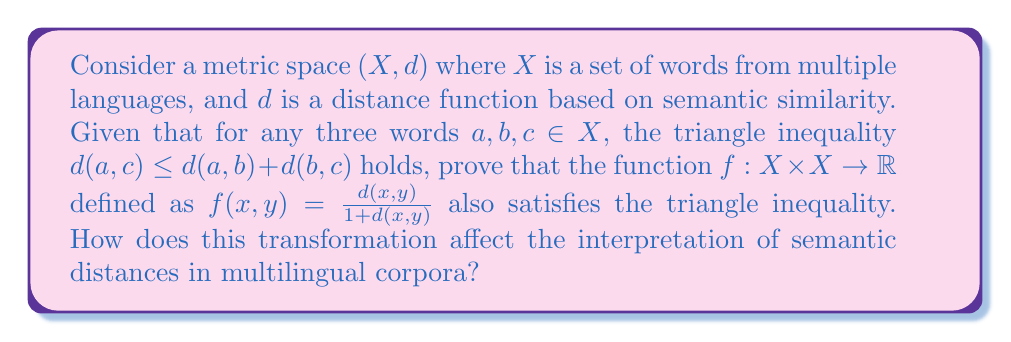Can you answer this question? To prove that $f(x,y) = \frac{d(x,y)}{1 + d(x,y)}$ satisfies the triangle inequality, we need to show that for any $a, b, c \in X$:

$$f(a,c) \leq f(a,b) + f(b,c)$$

Let's approach this step-by-step:

1) First, we know that $d(a,c) \leq d(a,b) + d(b,c)$ (given triangle inequality for $d$).

2) Divide both sides by $1 + d(a,c)$:

   $$\frac{d(a,c)}{1 + d(a,c)} \leq \frac{d(a,b) + d(b,c)}{1 + d(a,c)}$$

3) The left side is now $f(a,c)$. We need to show that the right side is $\leq f(a,b) + f(b,c)$.

4) Consider the function $g(x) = \frac{x}{1+x}$ for $x \geq 0$. This function is increasing and concave, which means:

   $$g(x+y) \leq g(x) + g(y)$$ for all $x,y \geq 0$

5) Applying this to our case:

   $$\frac{d(a,b) + d(b,c)}{1 + (d(a,b) + d(b,c))} \leq \frac{d(a,b)}{1 + d(a,b)} + \frac{d(b,c)}{1 + d(b,c)} = f(a,b) + f(b,c)$$

6) Since $d(a,c) \leq d(a,b) + d(b,c)$, we have $1 + d(a,c) \leq 1 + (d(a,b) + d(b,c))$

7) Therefore:

   $$\frac{d(a,b) + d(b,c)}{1 + d(a,c)} \geq \frac{d(a,b) + d(b,c)}{1 + (d(a,b) + d(b,c))}$$

8) Combining steps 2, 5, and 7:

   $$f(a,c) = \frac{d(a,c)}{1 + d(a,c)} \leq \frac{d(a,b) + d(b,c)}{1 + d(a,c)} \leq f(a,b) + f(b,c)$$

Thus, we have proved that $f$ satisfies the triangle inequality.

Regarding the interpretation of semantic distances in multilingual corpora:

1) The transformation $f(x,y) = \frac{d(x,y)}{1 + d(x,y)}$ maps the original distances to the interval $[0,1)$.

2) This normalization can be helpful when comparing semantic distances across different language pairs or different semantic spaces.

3) The transformation preserves the order of distances but compresses larger distances more than smaller ones. This means that in the transformed space, very distant concepts appear relatively closer, while maintaining the distinction between closely related concepts.

4) This compression effect could be particularly useful in multilingual settings where direct translation equivalents might be very close in the original space, but culturally specific concepts might be very far apart. The transformation helps to create a more balanced representation of these relationships.
Answer: The function $f(x,y) = \frac{d(x,y)}{1 + d(x,y)}$ satisfies the triangle inequality. This transformation normalizes semantic distances to the interval $[0,1)$, preserving the order of distances while compressing larger distances more than smaller ones. This can provide a more balanced representation of semantic relationships in multilingual corpora, especially when comparing across different language pairs or semantic spaces. 